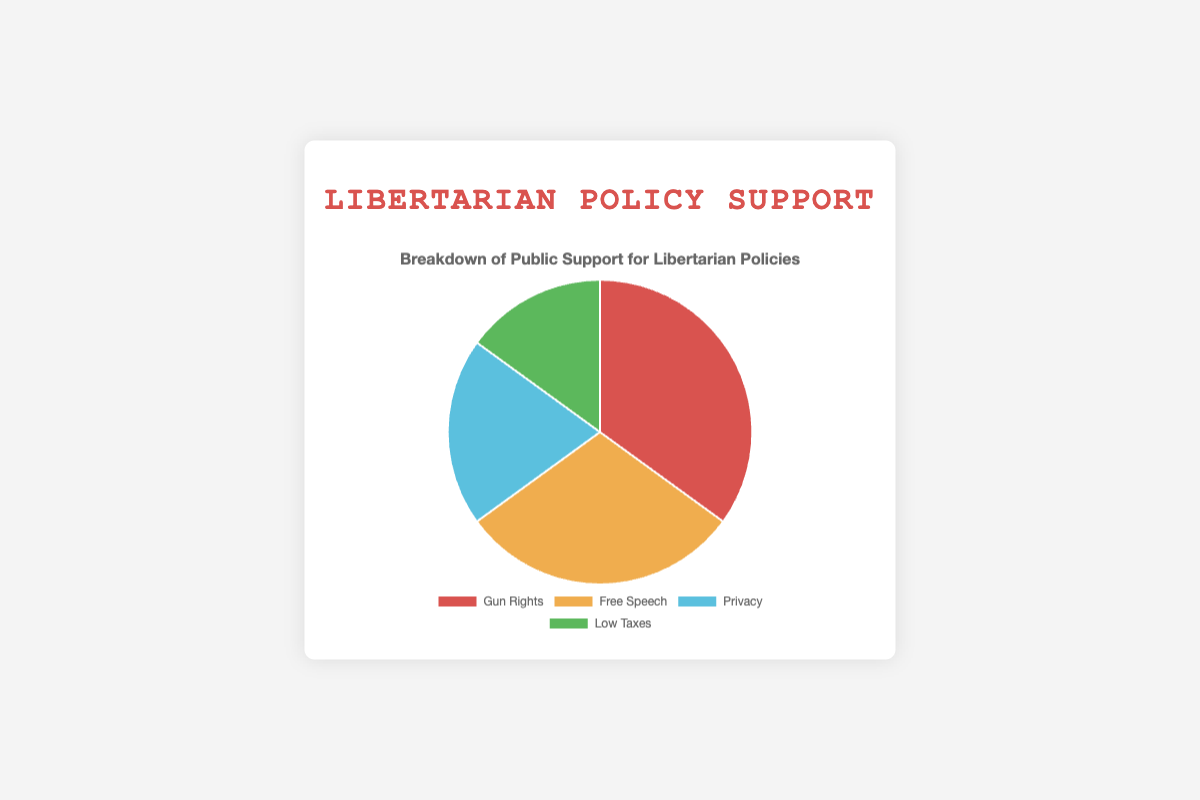Which policy has the highest public support? The figure shows that the segment representing Gun Rights is the largest.
Answer: Gun Rights Which policy has the least public support? By observing the smallest segment in the pie chart, which is Low Taxes, we can determine it has the least support.
Answer: Low Taxes What is the combined support for Free Speech and Privacy? Free Speech has 30% support and Privacy has 20%. Adding these values gives 30% + 20% = 50%.
Answer: 50% Is the support for Gun Rights greater than the combined support for Privacy and Low Taxes? Gun Rights has 35% support, while the combined support for Privacy and Low Taxes is 20% + 15% = 35%. Comparing these, they are equal.
Answer: No, they are equal What fraction of the total support is given to Low Taxes? The figure assigns 15% to Low Taxes. This represents the fraction 15/100 or 15%.
Answer: 15% How much more support does Gun Rights have compared to Low Taxes? Gun Rights has 35% support and Low Taxes has 15%. The difference is 35% - 15% = 20%.
Answer: 20% Which color represents the support for Privacy? The color segment for Privacy in the pie chart is a shade of blue.
Answer: Blue Rank the policies from highest to lowest support. The segments show Gun Rights (35%), followed by Free Speech (30%), Privacy (20%), and Low Taxes (15%). The ranking from highest to lowest is Gun Rights, Free Speech, Privacy, Low Taxes.
Answer: Gun Rights, Free Speech, Privacy, Low Taxes What is the difference in support between the two policies with the highest public support? The highest supports are Gun Rights (35%) and Free Speech (30%). The difference is 35% - 30% = 5%.
Answer: 5% If the total public support is represented by a circle, what portion of the circle is occupied by policies other than Gun Rights? The support for Gun Rights is 35%, so the combined support for all other policies is 100% - 35% = 65%.
Answer: 65% 